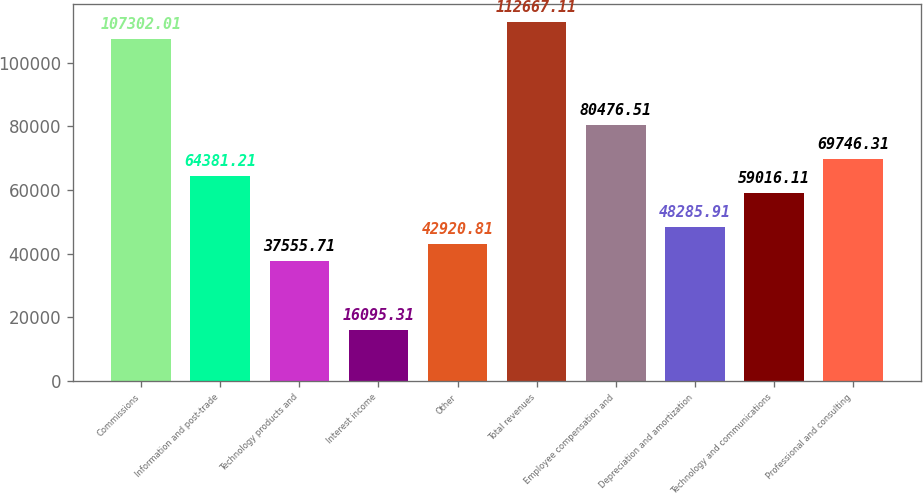<chart> <loc_0><loc_0><loc_500><loc_500><bar_chart><fcel>Commissions<fcel>Information and post-trade<fcel>Technology products and<fcel>Interest income<fcel>Other<fcel>Total revenues<fcel>Employee compensation and<fcel>Depreciation and amortization<fcel>Technology and communications<fcel>Professional and consulting<nl><fcel>107302<fcel>64381.2<fcel>37555.7<fcel>16095.3<fcel>42920.8<fcel>112667<fcel>80476.5<fcel>48285.9<fcel>59016.1<fcel>69746.3<nl></chart> 